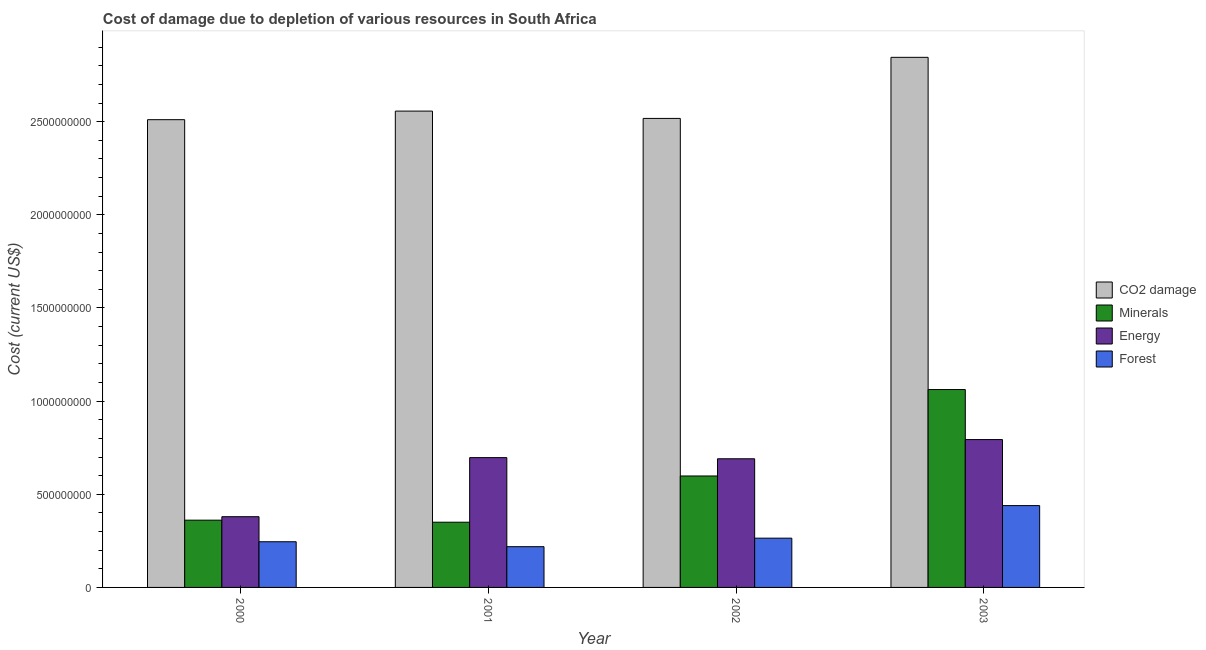How many groups of bars are there?
Give a very brief answer. 4. Are the number of bars per tick equal to the number of legend labels?
Ensure brevity in your answer.  Yes. Are the number of bars on each tick of the X-axis equal?
Your response must be concise. Yes. How many bars are there on the 2nd tick from the left?
Provide a succinct answer. 4. How many bars are there on the 4th tick from the right?
Give a very brief answer. 4. What is the cost of damage due to depletion of energy in 2001?
Make the answer very short. 6.97e+08. Across all years, what is the maximum cost of damage due to depletion of forests?
Provide a short and direct response. 4.39e+08. Across all years, what is the minimum cost of damage due to depletion of energy?
Your answer should be very brief. 3.80e+08. In which year was the cost of damage due to depletion of energy maximum?
Give a very brief answer. 2003. In which year was the cost of damage due to depletion of coal minimum?
Provide a succinct answer. 2000. What is the total cost of damage due to depletion of forests in the graph?
Your response must be concise. 1.17e+09. What is the difference between the cost of damage due to depletion of coal in 2000 and that in 2003?
Keep it short and to the point. -3.35e+08. What is the difference between the cost of damage due to depletion of energy in 2003 and the cost of damage due to depletion of minerals in 2002?
Ensure brevity in your answer.  1.03e+08. What is the average cost of damage due to depletion of coal per year?
Offer a terse response. 2.61e+09. In the year 2003, what is the difference between the cost of damage due to depletion of forests and cost of damage due to depletion of coal?
Give a very brief answer. 0. What is the ratio of the cost of damage due to depletion of coal in 2000 to that in 2001?
Offer a very short reply. 0.98. Is the cost of damage due to depletion of energy in 2000 less than that in 2003?
Offer a terse response. Yes. Is the difference between the cost of damage due to depletion of coal in 2001 and 2003 greater than the difference between the cost of damage due to depletion of forests in 2001 and 2003?
Offer a terse response. No. What is the difference between the highest and the second highest cost of damage due to depletion of minerals?
Keep it short and to the point. 4.64e+08. What is the difference between the highest and the lowest cost of damage due to depletion of forests?
Your answer should be compact. 2.21e+08. Is the sum of the cost of damage due to depletion of minerals in 2002 and 2003 greater than the maximum cost of damage due to depletion of forests across all years?
Keep it short and to the point. Yes. What does the 2nd bar from the left in 2002 represents?
Keep it short and to the point. Minerals. What does the 3rd bar from the right in 2000 represents?
Provide a succinct answer. Minerals. How many bars are there?
Make the answer very short. 16. How many years are there in the graph?
Your answer should be very brief. 4. What is the difference between two consecutive major ticks on the Y-axis?
Keep it short and to the point. 5.00e+08. Are the values on the major ticks of Y-axis written in scientific E-notation?
Your answer should be very brief. No. Where does the legend appear in the graph?
Provide a succinct answer. Center right. How are the legend labels stacked?
Provide a succinct answer. Vertical. What is the title of the graph?
Your answer should be compact. Cost of damage due to depletion of various resources in South Africa . Does "Offering training" appear as one of the legend labels in the graph?
Provide a short and direct response. No. What is the label or title of the X-axis?
Offer a very short reply. Year. What is the label or title of the Y-axis?
Keep it short and to the point. Cost (current US$). What is the Cost (current US$) in CO2 damage in 2000?
Your answer should be very brief. 2.51e+09. What is the Cost (current US$) in Minerals in 2000?
Ensure brevity in your answer.  3.61e+08. What is the Cost (current US$) of Energy in 2000?
Provide a short and direct response. 3.80e+08. What is the Cost (current US$) in Forest in 2000?
Give a very brief answer. 2.45e+08. What is the Cost (current US$) of CO2 damage in 2001?
Provide a short and direct response. 2.56e+09. What is the Cost (current US$) of Minerals in 2001?
Ensure brevity in your answer.  3.50e+08. What is the Cost (current US$) of Energy in 2001?
Offer a terse response. 6.97e+08. What is the Cost (current US$) in Forest in 2001?
Give a very brief answer. 2.19e+08. What is the Cost (current US$) in CO2 damage in 2002?
Your answer should be very brief. 2.52e+09. What is the Cost (current US$) in Minerals in 2002?
Give a very brief answer. 5.98e+08. What is the Cost (current US$) in Energy in 2002?
Provide a short and direct response. 6.91e+08. What is the Cost (current US$) in Forest in 2002?
Your response must be concise. 2.64e+08. What is the Cost (current US$) of CO2 damage in 2003?
Provide a short and direct response. 2.85e+09. What is the Cost (current US$) of Minerals in 2003?
Your answer should be compact. 1.06e+09. What is the Cost (current US$) in Energy in 2003?
Give a very brief answer. 7.94e+08. What is the Cost (current US$) in Forest in 2003?
Your answer should be very brief. 4.39e+08. Across all years, what is the maximum Cost (current US$) in CO2 damage?
Make the answer very short. 2.85e+09. Across all years, what is the maximum Cost (current US$) of Minerals?
Your answer should be very brief. 1.06e+09. Across all years, what is the maximum Cost (current US$) of Energy?
Your answer should be very brief. 7.94e+08. Across all years, what is the maximum Cost (current US$) in Forest?
Your response must be concise. 4.39e+08. Across all years, what is the minimum Cost (current US$) in CO2 damage?
Offer a very short reply. 2.51e+09. Across all years, what is the minimum Cost (current US$) of Minerals?
Your answer should be compact. 3.50e+08. Across all years, what is the minimum Cost (current US$) of Energy?
Provide a succinct answer. 3.80e+08. Across all years, what is the minimum Cost (current US$) in Forest?
Your response must be concise. 2.19e+08. What is the total Cost (current US$) in CO2 damage in the graph?
Make the answer very short. 1.04e+1. What is the total Cost (current US$) of Minerals in the graph?
Your answer should be very brief. 2.37e+09. What is the total Cost (current US$) in Energy in the graph?
Offer a very short reply. 2.56e+09. What is the total Cost (current US$) of Forest in the graph?
Make the answer very short. 1.17e+09. What is the difference between the Cost (current US$) of CO2 damage in 2000 and that in 2001?
Offer a terse response. -4.60e+07. What is the difference between the Cost (current US$) of Minerals in 2000 and that in 2001?
Keep it short and to the point. 1.09e+07. What is the difference between the Cost (current US$) of Energy in 2000 and that in 2001?
Offer a terse response. -3.17e+08. What is the difference between the Cost (current US$) of Forest in 2000 and that in 2001?
Your answer should be compact. 2.66e+07. What is the difference between the Cost (current US$) of CO2 damage in 2000 and that in 2002?
Give a very brief answer. -6.77e+06. What is the difference between the Cost (current US$) of Minerals in 2000 and that in 2002?
Make the answer very short. -2.37e+08. What is the difference between the Cost (current US$) in Energy in 2000 and that in 2002?
Your answer should be very brief. -3.11e+08. What is the difference between the Cost (current US$) of Forest in 2000 and that in 2002?
Offer a terse response. -1.91e+07. What is the difference between the Cost (current US$) in CO2 damage in 2000 and that in 2003?
Provide a succinct answer. -3.35e+08. What is the difference between the Cost (current US$) in Minerals in 2000 and that in 2003?
Your answer should be very brief. -7.01e+08. What is the difference between the Cost (current US$) in Energy in 2000 and that in 2003?
Offer a terse response. -4.14e+08. What is the difference between the Cost (current US$) in Forest in 2000 and that in 2003?
Your answer should be compact. -1.94e+08. What is the difference between the Cost (current US$) of CO2 damage in 2001 and that in 2002?
Provide a succinct answer. 3.92e+07. What is the difference between the Cost (current US$) of Minerals in 2001 and that in 2002?
Give a very brief answer. -2.48e+08. What is the difference between the Cost (current US$) of Energy in 2001 and that in 2002?
Offer a very short reply. 6.14e+06. What is the difference between the Cost (current US$) in Forest in 2001 and that in 2002?
Your answer should be very brief. -4.57e+07. What is the difference between the Cost (current US$) of CO2 damage in 2001 and that in 2003?
Give a very brief answer. -2.89e+08. What is the difference between the Cost (current US$) in Minerals in 2001 and that in 2003?
Your answer should be very brief. -7.12e+08. What is the difference between the Cost (current US$) in Energy in 2001 and that in 2003?
Your response must be concise. -9.69e+07. What is the difference between the Cost (current US$) in Forest in 2001 and that in 2003?
Keep it short and to the point. -2.21e+08. What is the difference between the Cost (current US$) in CO2 damage in 2002 and that in 2003?
Your response must be concise. -3.28e+08. What is the difference between the Cost (current US$) of Minerals in 2002 and that in 2003?
Ensure brevity in your answer.  -4.64e+08. What is the difference between the Cost (current US$) of Energy in 2002 and that in 2003?
Your response must be concise. -1.03e+08. What is the difference between the Cost (current US$) in Forest in 2002 and that in 2003?
Offer a very short reply. -1.75e+08. What is the difference between the Cost (current US$) in CO2 damage in 2000 and the Cost (current US$) in Minerals in 2001?
Your answer should be very brief. 2.16e+09. What is the difference between the Cost (current US$) in CO2 damage in 2000 and the Cost (current US$) in Energy in 2001?
Your response must be concise. 1.81e+09. What is the difference between the Cost (current US$) of CO2 damage in 2000 and the Cost (current US$) of Forest in 2001?
Offer a very short reply. 2.29e+09. What is the difference between the Cost (current US$) in Minerals in 2000 and the Cost (current US$) in Energy in 2001?
Provide a succinct answer. -3.36e+08. What is the difference between the Cost (current US$) of Minerals in 2000 and the Cost (current US$) of Forest in 2001?
Make the answer very short. 1.42e+08. What is the difference between the Cost (current US$) in Energy in 2000 and the Cost (current US$) in Forest in 2001?
Give a very brief answer. 1.61e+08. What is the difference between the Cost (current US$) in CO2 damage in 2000 and the Cost (current US$) in Minerals in 2002?
Provide a short and direct response. 1.91e+09. What is the difference between the Cost (current US$) in CO2 damage in 2000 and the Cost (current US$) in Energy in 2002?
Keep it short and to the point. 1.82e+09. What is the difference between the Cost (current US$) of CO2 damage in 2000 and the Cost (current US$) of Forest in 2002?
Your answer should be very brief. 2.25e+09. What is the difference between the Cost (current US$) of Minerals in 2000 and the Cost (current US$) of Energy in 2002?
Make the answer very short. -3.30e+08. What is the difference between the Cost (current US$) of Minerals in 2000 and the Cost (current US$) of Forest in 2002?
Your response must be concise. 9.66e+07. What is the difference between the Cost (current US$) of Energy in 2000 and the Cost (current US$) of Forest in 2002?
Ensure brevity in your answer.  1.15e+08. What is the difference between the Cost (current US$) in CO2 damage in 2000 and the Cost (current US$) in Minerals in 2003?
Offer a terse response. 1.45e+09. What is the difference between the Cost (current US$) of CO2 damage in 2000 and the Cost (current US$) of Energy in 2003?
Your response must be concise. 1.72e+09. What is the difference between the Cost (current US$) in CO2 damage in 2000 and the Cost (current US$) in Forest in 2003?
Offer a very short reply. 2.07e+09. What is the difference between the Cost (current US$) of Minerals in 2000 and the Cost (current US$) of Energy in 2003?
Your response must be concise. -4.33e+08. What is the difference between the Cost (current US$) in Minerals in 2000 and the Cost (current US$) in Forest in 2003?
Keep it short and to the point. -7.82e+07. What is the difference between the Cost (current US$) in Energy in 2000 and the Cost (current US$) in Forest in 2003?
Offer a very short reply. -5.95e+07. What is the difference between the Cost (current US$) of CO2 damage in 2001 and the Cost (current US$) of Minerals in 2002?
Your answer should be compact. 1.96e+09. What is the difference between the Cost (current US$) in CO2 damage in 2001 and the Cost (current US$) in Energy in 2002?
Give a very brief answer. 1.87e+09. What is the difference between the Cost (current US$) of CO2 damage in 2001 and the Cost (current US$) of Forest in 2002?
Make the answer very short. 2.29e+09. What is the difference between the Cost (current US$) of Minerals in 2001 and the Cost (current US$) of Energy in 2002?
Ensure brevity in your answer.  -3.40e+08. What is the difference between the Cost (current US$) in Minerals in 2001 and the Cost (current US$) in Forest in 2002?
Ensure brevity in your answer.  8.57e+07. What is the difference between the Cost (current US$) in Energy in 2001 and the Cost (current US$) in Forest in 2002?
Keep it short and to the point. 4.32e+08. What is the difference between the Cost (current US$) of CO2 damage in 2001 and the Cost (current US$) of Minerals in 2003?
Make the answer very short. 1.49e+09. What is the difference between the Cost (current US$) of CO2 damage in 2001 and the Cost (current US$) of Energy in 2003?
Offer a terse response. 1.76e+09. What is the difference between the Cost (current US$) of CO2 damage in 2001 and the Cost (current US$) of Forest in 2003?
Give a very brief answer. 2.12e+09. What is the difference between the Cost (current US$) of Minerals in 2001 and the Cost (current US$) of Energy in 2003?
Your answer should be compact. -4.44e+08. What is the difference between the Cost (current US$) of Minerals in 2001 and the Cost (current US$) of Forest in 2003?
Your response must be concise. -8.92e+07. What is the difference between the Cost (current US$) of Energy in 2001 and the Cost (current US$) of Forest in 2003?
Your response must be concise. 2.57e+08. What is the difference between the Cost (current US$) of CO2 damage in 2002 and the Cost (current US$) of Minerals in 2003?
Offer a very short reply. 1.46e+09. What is the difference between the Cost (current US$) of CO2 damage in 2002 and the Cost (current US$) of Energy in 2003?
Ensure brevity in your answer.  1.72e+09. What is the difference between the Cost (current US$) of CO2 damage in 2002 and the Cost (current US$) of Forest in 2003?
Your answer should be very brief. 2.08e+09. What is the difference between the Cost (current US$) of Minerals in 2002 and the Cost (current US$) of Energy in 2003?
Offer a terse response. -1.95e+08. What is the difference between the Cost (current US$) of Minerals in 2002 and the Cost (current US$) of Forest in 2003?
Give a very brief answer. 1.59e+08. What is the difference between the Cost (current US$) of Energy in 2002 and the Cost (current US$) of Forest in 2003?
Offer a very short reply. 2.51e+08. What is the average Cost (current US$) of CO2 damage per year?
Your response must be concise. 2.61e+09. What is the average Cost (current US$) in Minerals per year?
Provide a short and direct response. 5.93e+08. What is the average Cost (current US$) in Energy per year?
Your answer should be very brief. 6.40e+08. What is the average Cost (current US$) in Forest per year?
Your answer should be compact. 2.92e+08. In the year 2000, what is the difference between the Cost (current US$) of CO2 damage and Cost (current US$) of Minerals?
Keep it short and to the point. 2.15e+09. In the year 2000, what is the difference between the Cost (current US$) of CO2 damage and Cost (current US$) of Energy?
Offer a very short reply. 2.13e+09. In the year 2000, what is the difference between the Cost (current US$) in CO2 damage and Cost (current US$) in Forest?
Keep it short and to the point. 2.27e+09. In the year 2000, what is the difference between the Cost (current US$) in Minerals and Cost (current US$) in Energy?
Your answer should be very brief. -1.87e+07. In the year 2000, what is the difference between the Cost (current US$) in Minerals and Cost (current US$) in Forest?
Ensure brevity in your answer.  1.16e+08. In the year 2000, what is the difference between the Cost (current US$) of Energy and Cost (current US$) of Forest?
Your answer should be compact. 1.34e+08. In the year 2001, what is the difference between the Cost (current US$) of CO2 damage and Cost (current US$) of Minerals?
Offer a very short reply. 2.21e+09. In the year 2001, what is the difference between the Cost (current US$) of CO2 damage and Cost (current US$) of Energy?
Provide a short and direct response. 1.86e+09. In the year 2001, what is the difference between the Cost (current US$) in CO2 damage and Cost (current US$) in Forest?
Give a very brief answer. 2.34e+09. In the year 2001, what is the difference between the Cost (current US$) of Minerals and Cost (current US$) of Energy?
Offer a very short reply. -3.47e+08. In the year 2001, what is the difference between the Cost (current US$) of Minerals and Cost (current US$) of Forest?
Offer a terse response. 1.31e+08. In the year 2001, what is the difference between the Cost (current US$) of Energy and Cost (current US$) of Forest?
Give a very brief answer. 4.78e+08. In the year 2002, what is the difference between the Cost (current US$) of CO2 damage and Cost (current US$) of Minerals?
Your answer should be compact. 1.92e+09. In the year 2002, what is the difference between the Cost (current US$) in CO2 damage and Cost (current US$) in Energy?
Provide a short and direct response. 1.83e+09. In the year 2002, what is the difference between the Cost (current US$) in CO2 damage and Cost (current US$) in Forest?
Your answer should be compact. 2.25e+09. In the year 2002, what is the difference between the Cost (current US$) in Minerals and Cost (current US$) in Energy?
Ensure brevity in your answer.  -9.24e+07. In the year 2002, what is the difference between the Cost (current US$) of Minerals and Cost (current US$) of Forest?
Make the answer very short. 3.34e+08. In the year 2002, what is the difference between the Cost (current US$) of Energy and Cost (current US$) of Forest?
Give a very brief answer. 4.26e+08. In the year 2003, what is the difference between the Cost (current US$) in CO2 damage and Cost (current US$) in Minerals?
Ensure brevity in your answer.  1.78e+09. In the year 2003, what is the difference between the Cost (current US$) of CO2 damage and Cost (current US$) of Energy?
Provide a succinct answer. 2.05e+09. In the year 2003, what is the difference between the Cost (current US$) of CO2 damage and Cost (current US$) of Forest?
Offer a very short reply. 2.41e+09. In the year 2003, what is the difference between the Cost (current US$) of Minerals and Cost (current US$) of Energy?
Keep it short and to the point. 2.69e+08. In the year 2003, what is the difference between the Cost (current US$) of Minerals and Cost (current US$) of Forest?
Offer a very short reply. 6.23e+08. In the year 2003, what is the difference between the Cost (current US$) in Energy and Cost (current US$) in Forest?
Your response must be concise. 3.54e+08. What is the ratio of the Cost (current US$) of Minerals in 2000 to that in 2001?
Keep it short and to the point. 1.03. What is the ratio of the Cost (current US$) in Energy in 2000 to that in 2001?
Your response must be concise. 0.55. What is the ratio of the Cost (current US$) in Forest in 2000 to that in 2001?
Ensure brevity in your answer.  1.12. What is the ratio of the Cost (current US$) of CO2 damage in 2000 to that in 2002?
Provide a short and direct response. 1. What is the ratio of the Cost (current US$) in Minerals in 2000 to that in 2002?
Ensure brevity in your answer.  0.6. What is the ratio of the Cost (current US$) in Energy in 2000 to that in 2002?
Provide a short and direct response. 0.55. What is the ratio of the Cost (current US$) in Forest in 2000 to that in 2002?
Offer a terse response. 0.93. What is the ratio of the Cost (current US$) in CO2 damage in 2000 to that in 2003?
Provide a short and direct response. 0.88. What is the ratio of the Cost (current US$) of Minerals in 2000 to that in 2003?
Provide a short and direct response. 0.34. What is the ratio of the Cost (current US$) of Energy in 2000 to that in 2003?
Make the answer very short. 0.48. What is the ratio of the Cost (current US$) in Forest in 2000 to that in 2003?
Your answer should be very brief. 0.56. What is the ratio of the Cost (current US$) of CO2 damage in 2001 to that in 2002?
Provide a short and direct response. 1.02. What is the ratio of the Cost (current US$) of Minerals in 2001 to that in 2002?
Make the answer very short. 0.59. What is the ratio of the Cost (current US$) in Energy in 2001 to that in 2002?
Offer a very short reply. 1.01. What is the ratio of the Cost (current US$) in Forest in 2001 to that in 2002?
Your answer should be very brief. 0.83. What is the ratio of the Cost (current US$) in CO2 damage in 2001 to that in 2003?
Ensure brevity in your answer.  0.9. What is the ratio of the Cost (current US$) of Minerals in 2001 to that in 2003?
Provide a succinct answer. 0.33. What is the ratio of the Cost (current US$) in Energy in 2001 to that in 2003?
Make the answer very short. 0.88. What is the ratio of the Cost (current US$) in Forest in 2001 to that in 2003?
Give a very brief answer. 0.5. What is the ratio of the Cost (current US$) in CO2 damage in 2002 to that in 2003?
Make the answer very short. 0.88. What is the ratio of the Cost (current US$) of Minerals in 2002 to that in 2003?
Keep it short and to the point. 0.56. What is the ratio of the Cost (current US$) in Energy in 2002 to that in 2003?
Ensure brevity in your answer.  0.87. What is the ratio of the Cost (current US$) of Forest in 2002 to that in 2003?
Your answer should be compact. 0.6. What is the difference between the highest and the second highest Cost (current US$) in CO2 damage?
Offer a terse response. 2.89e+08. What is the difference between the highest and the second highest Cost (current US$) in Minerals?
Offer a terse response. 4.64e+08. What is the difference between the highest and the second highest Cost (current US$) of Energy?
Make the answer very short. 9.69e+07. What is the difference between the highest and the second highest Cost (current US$) of Forest?
Offer a very short reply. 1.75e+08. What is the difference between the highest and the lowest Cost (current US$) of CO2 damage?
Your answer should be very brief. 3.35e+08. What is the difference between the highest and the lowest Cost (current US$) in Minerals?
Make the answer very short. 7.12e+08. What is the difference between the highest and the lowest Cost (current US$) of Energy?
Make the answer very short. 4.14e+08. What is the difference between the highest and the lowest Cost (current US$) in Forest?
Keep it short and to the point. 2.21e+08. 